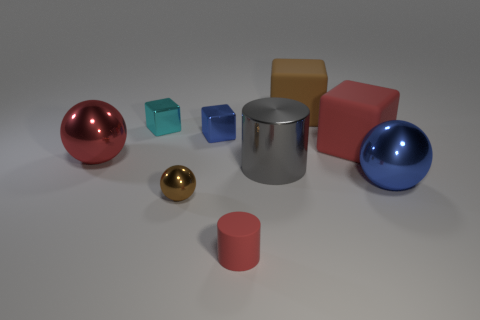Subtract all red blocks. How many blocks are left? 3 Add 1 big red things. How many objects exist? 10 Subtract all red cubes. How many cubes are left? 3 Subtract all yellow spheres. Subtract all red blocks. How many spheres are left? 3 Subtract 0 gray blocks. How many objects are left? 9 Subtract all spheres. How many objects are left? 6 Subtract all big brown things. Subtract all shiny cylinders. How many objects are left? 7 Add 2 shiny objects. How many shiny objects are left? 8 Add 4 big shiny things. How many big shiny things exist? 7 